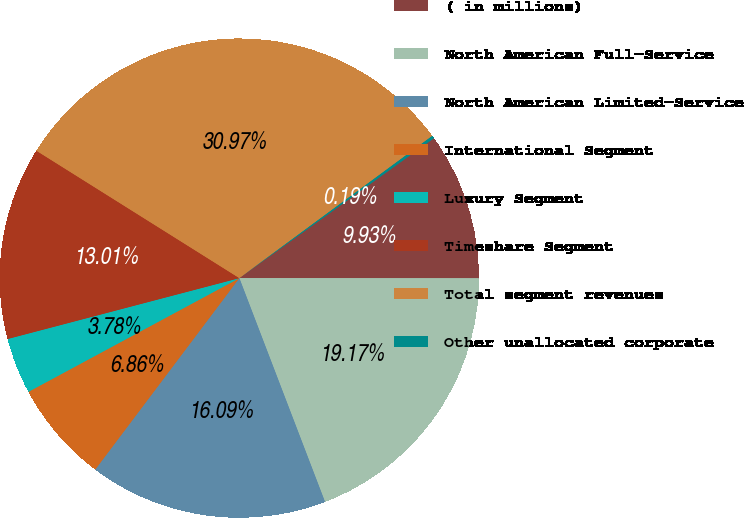<chart> <loc_0><loc_0><loc_500><loc_500><pie_chart><fcel>( in millions)<fcel>North American Full-Service<fcel>North American Limited-Service<fcel>International Segment<fcel>Luxury Segment<fcel>Timeshare Segment<fcel>Total segment revenues<fcel>Other unallocated corporate<nl><fcel>9.93%<fcel>19.17%<fcel>16.09%<fcel>6.86%<fcel>3.78%<fcel>13.01%<fcel>30.97%<fcel>0.19%<nl></chart> 